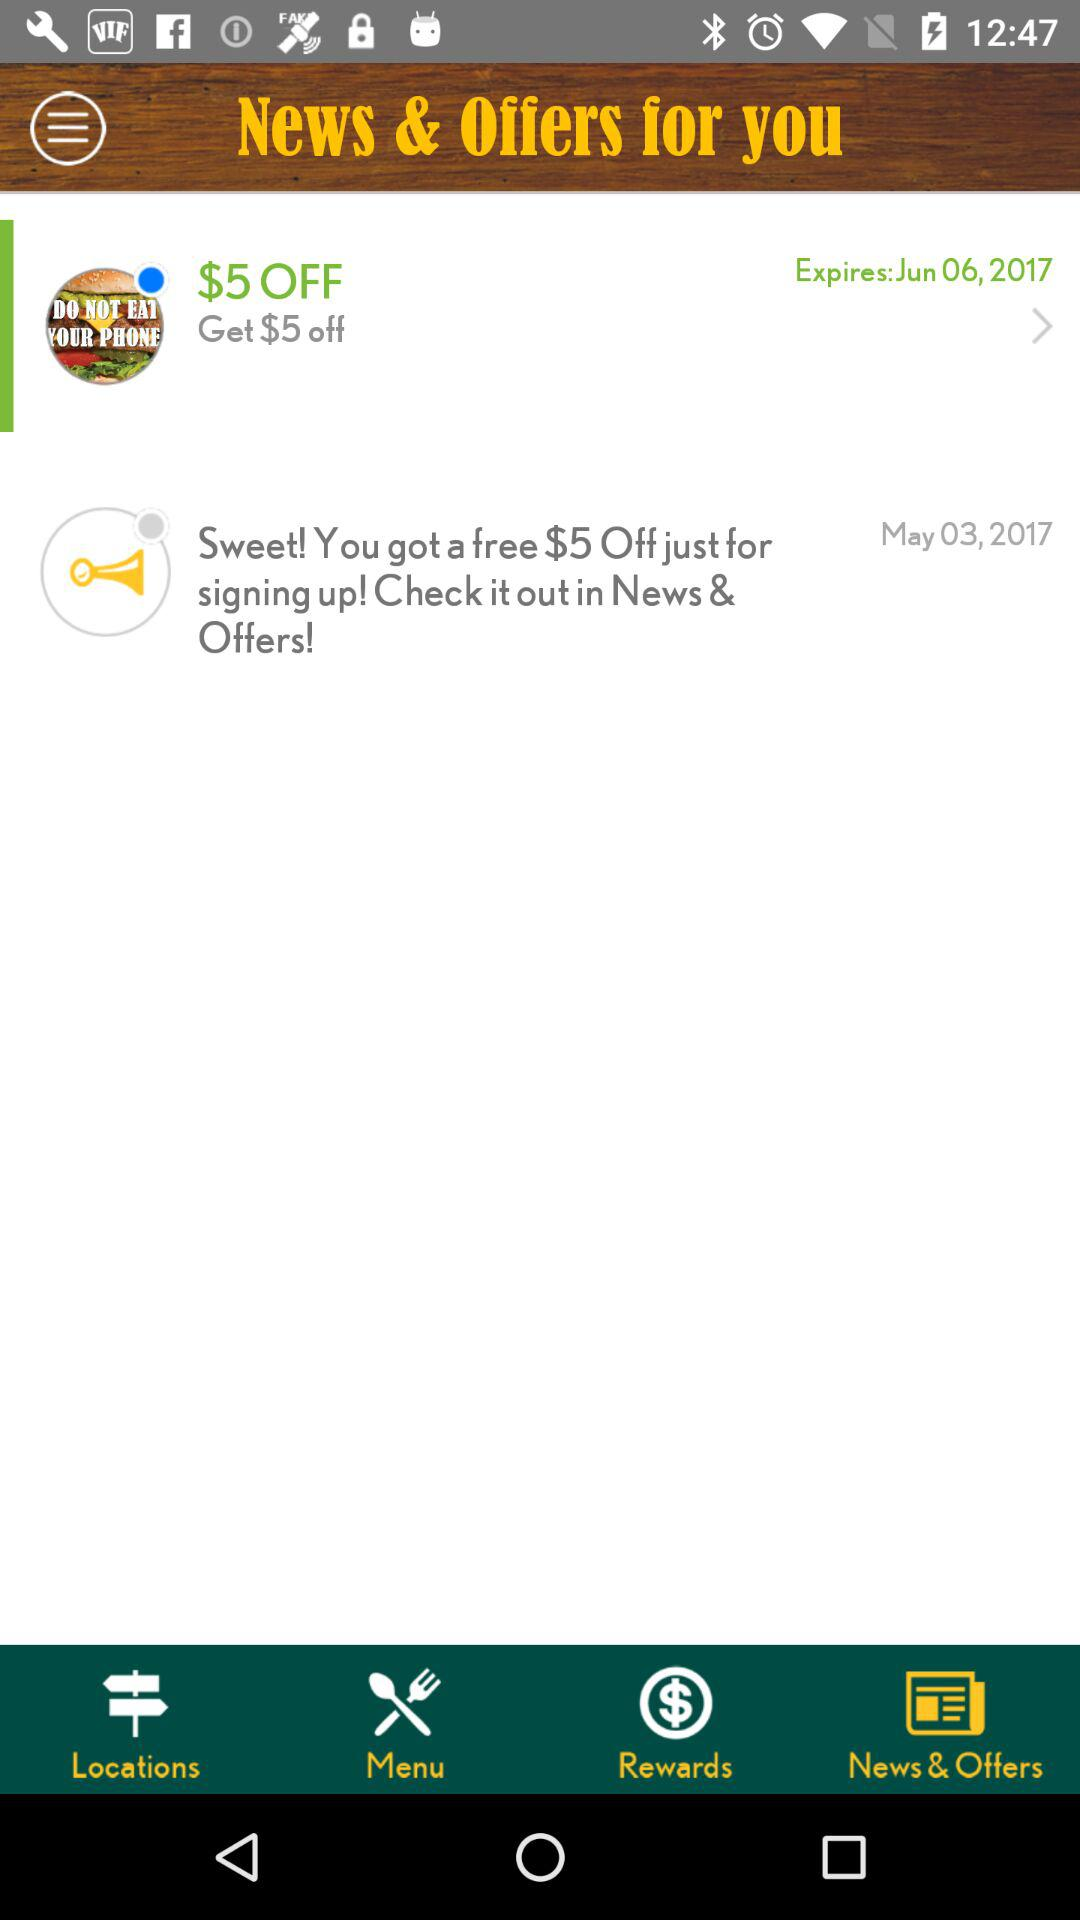Which tab has been selected? The selected tab is "News & Offers". 